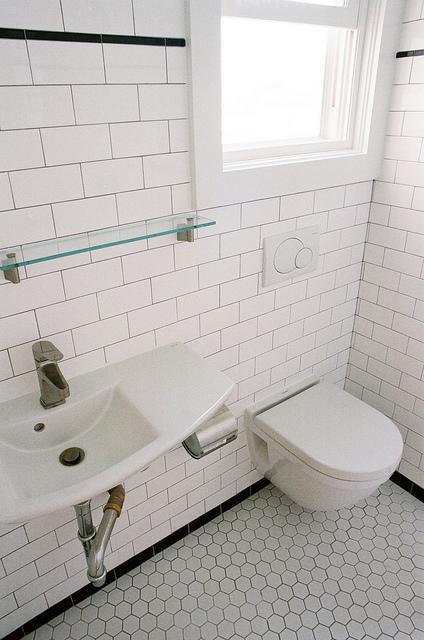How many toilets are in the photo?
Give a very brief answer. 1. 